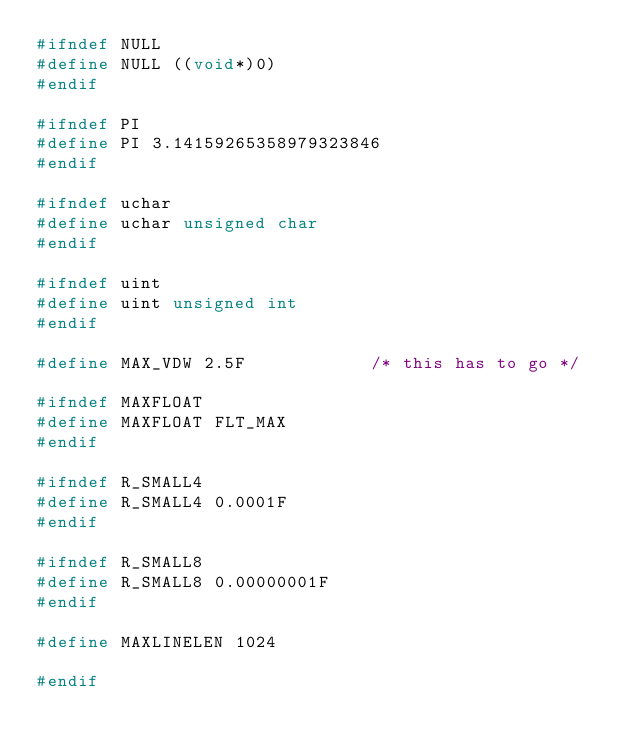Convert code to text. <code><loc_0><loc_0><loc_500><loc_500><_C_>#ifndef NULL
#define NULL ((void*)0)
#endif

#ifndef PI
#define PI 3.14159265358979323846
#endif

#ifndef uchar
#define uchar unsigned char
#endif

#ifndef uint
#define uint unsigned int
#endif

#define MAX_VDW 2.5F            /* this has to go */

#ifndef MAXFLOAT
#define MAXFLOAT FLT_MAX
#endif

#ifndef R_SMALL4
#define R_SMALL4 0.0001F
#endif

#ifndef R_SMALL8
#define R_SMALL8 0.00000001F
#endif

#define MAXLINELEN 1024

#endif
</code> 